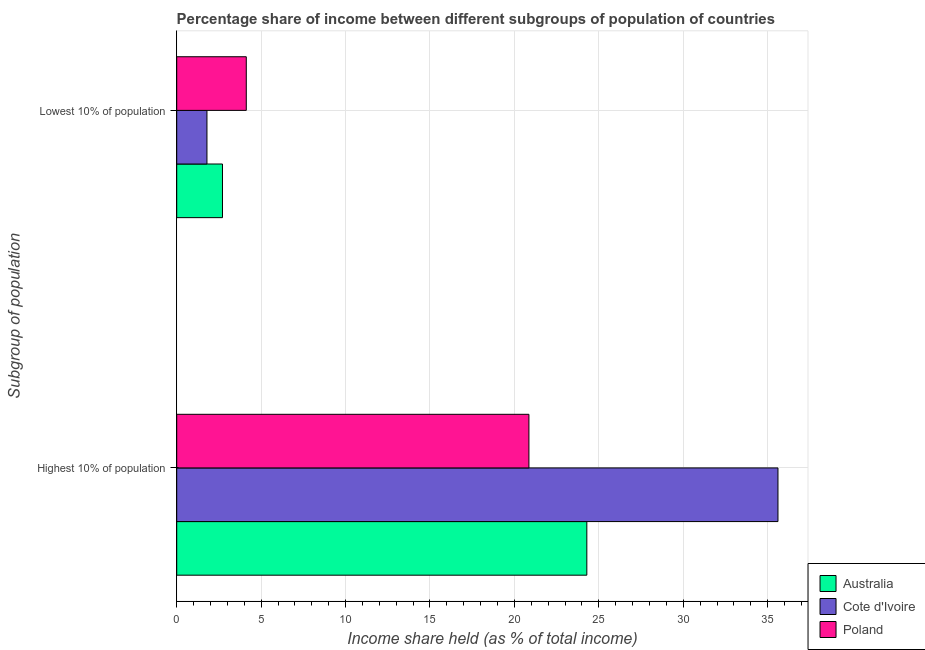How many groups of bars are there?
Provide a succinct answer. 2. How many bars are there on the 2nd tick from the top?
Your answer should be very brief. 3. How many bars are there on the 1st tick from the bottom?
Offer a terse response. 3. What is the label of the 1st group of bars from the top?
Provide a short and direct response. Lowest 10% of population. What is the income share held by lowest 10% of the population in Australia?
Your answer should be compact. 2.71. Across all countries, what is the maximum income share held by lowest 10% of the population?
Your answer should be very brief. 4.12. Across all countries, what is the minimum income share held by lowest 10% of the population?
Offer a very short reply. 1.79. In which country was the income share held by highest 10% of the population minimum?
Your answer should be compact. Poland. What is the total income share held by highest 10% of the population in the graph?
Your answer should be compact. 80.76. What is the difference between the income share held by highest 10% of the population in Australia and that in Cote d'Ivoire?
Keep it short and to the point. -11.32. What is the difference between the income share held by lowest 10% of the population in Australia and the income share held by highest 10% of the population in Cote d'Ivoire?
Offer a very short reply. -32.9. What is the average income share held by highest 10% of the population per country?
Your response must be concise. 26.92. What is the difference between the income share held by lowest 10% of the population and income share held by highest 10% of the population in Poland?
Make the answer very short. -16.74. What is the ratio of the income share held by highest 10% of the population in Poland to that in Cote d'Ivoire?
Provide a short and direct response. 0.59. What does the 2nd bar from the top in Highest 10% of population represents?
Provide a short and direct response. Cote d'Ivoire. What does the 3rd bar from the bottom in Lowest 10% of population represents?
Provide a short and direct response. Poland. How many countries are there in the graph?
Your response must be concise. 3. What is the difference between two consecutive major ticks on the X-axis?
Keep it short and to the point. 5. Are the values on the major ticks of X-axis written in scientific E-notation?
Offer a terse response. No. Does the graph contain any zero values?
Your answer should be very brief. No. How many legend labels are there?
Keep it short and to the point. 3. How are the legend labels stacked?
Give a very brief answer. Vertical. What is the title of the graph?
Your answer should be very brief. Percentage share of income between different subgroups of population of countries. Does "Cote d'Ivoire" appear as one of the legend labels in the graph?
Provide a short and direct response. Yes. What is the label or title of the X-axis?
Keep it short and to the point. Income share held (as % of total income). What is the label or title of the Y-axis?
Provide a succinct answer. Subgroup of population. What is the Income share held (as % of total income) in Australia in Highest 10% of population?
Provide a succinct answer. 24.29. What is the Income share held (as % of total income) in Cote d'Ivoire in Highest 10% of population?
Ensure brevity in your answer.  35.61. What is the Income share held (as % of total income) in Poland in Highest 10% of population?
Your answer should be compact. 20.86. What is the Income share held (as % of total income) of Australia in Lowest 10% of population?
Provide a short and direct response. 2.71. What is the Income share held (as % of total income) of Cote d'Ivoire in Lowest 10% of population?
Offer a very short reply. 1.79. What is the Income share held (as % of total income) in Poland in Lowest 10% of population?
Your answer should be compact. 4.12. Across all Subgroup of population, what is the maximum Income share held (as % of total income) of Australia?
Give a very brief answer. 24.29. Across all Subgroup of population, what is the maximum Income share held (as % of total income) of Cote d'Ivoire?
Your answer should be very brief. 35.61. Across all Subgroup of population, what is the maximum Income share held (as % of total income) in Poland?
Provide a short and direct response. 20.86. Across all Subgroup of population, what is the minimum Income share held (as % of total income) in Australia?
Provide a succinct answer. 2.71. Across all Subgroup of population, what is the minimum Income share held (as % of total income) of Cote d'Ivoire?
Ensure brevity in your answer.  1.79. Across all Subgroup of population, what is the minimum Income share held (as % of total income) in Poland?
Give a very brief answer. 4.12. What is the total Income share held (as % of total income) in Australia in the graph?
Your answer should be very brief. 27. What is the total Income share held (as % of total income) in Cote d'Ivoire in the graph?
Give a very brief answer. 37.4. What is the total Income share held (as % of total income) in Poland in the graph?
Give a very brief answer. 24.98. What is the difference between the Income share held (as % of total income) of Australia in Highest 10% of population and that in Lowest 10% of population?
Provide a succinct answer. 21.58. What is the difference between the Income share held (as % of total income) in Cote d'Ivoire in Highest 10% of population and that in Lowest 10% of population?
Your response must be concise. 33.82. What is the difference between the Income share held (as % of total income) in Poland in Highest 10% of population and that in Lowest 10% of population?
Your response must be concise. 16.74. What is the difference between the Income share held (as % of total income) in Australia in Highest 10% of population and the Income share held (as % of total income) in Cote d'Ivoire in Lowest 10% of population?
Your response must be concise. 22.5. What is the difference between the Income share held (as % of total income) in Australia in Highest 10% of population and the Income share held (as % of total income) in Poland in Lowest 10% of population?
Your response must be concise. 20.17. What is the difference between the Income share held (as % of total income) in Cote d'Ivoire in Highest 10% of population and the Income share held (as % of total income) in Poland in Lowest 10% of population?
Ensure brevity in your answer.  31.49. What is the average Income share held (as % of total income) in Australia per Subgroup of population?
Your answer should be compact. 13.5. What is the average Income share held (as % of total income) of Cote d'Ivoire per Subgroup of population?
Your answer should be compact. 18.7. What is the average Income share held (as % of total income) of Poland per Subgroup of population?
Your answer should be compact. 12.49. What is the difference between the Income share held (as % of total income) of Australia and Income share held (as % of total income) of Cote d'Ivoire in Highest 10% of population?
Keep it short and to the point. -11.32. What is the difference between the Income share held (as % of total income) of Australia and Income share held (as % of total income) of Poland in Highest 10% of population?
Your answer should be compact. 3.43. What is the difference between the Income share held (as % of total income) in Cote d'Ivoire and Income share held (as % of total income) in Poland in Highest 10% of population?
Provide a short and direct response. 14.75. What is the difference between the Income share held (as % of total income) of Australia and Income share held (as % of total income) of Poland in Lowest 10% of population?
Keep it short and to the point. -1.41. What is the difference between the Income share held (as % of total income) of Cote d'Ivoire and Income share held (as % of total income) of Poland in Lowest 10% of population?
Make the answer very short. -2.33. What is the ratio of the Income share held (as % of total income) of Australia in Highest 10% of population to that in Lowest 10% of population?
Ensure brevity in your answer.  8.96. What is the ratio of the Income share held (as % of total income) in Cote d'Ivoire in Highest 10% of population to that in Lowest 10% of population?
Give a very brief answer. 19.89. What is the ratio of the Income share held (as % of total income) in Poland in Highest 10% of population to that in Lowest 10% of population?
Keep it short and to the point. 5.06. What is the difference between the highest and the second highest Income share held (as % of total income) of Australia?
Your answer should be very brief. 21.58. What is the difference between the highest and the second highest Income share held (as % of total income) in Cote d'Ivoire?
Your answer should be compact. 33.82. What is the difference between the highest and the second highest Income share held (as % of total income) in Poland?
Provide a short and direct response. 16.74. What is the difference between the highest and the lowest Income share held (as % of total income) in Australia?
Make the answer very short. 21.58. What is the difference between the highest and the lowest Income share held (as % of total income) in Cote d'Ivoire?
Keep it short and to the point. 33.82. What is the difference between the highest and the lowest Income share held (as % of total income) in Poland?
Your answer should be compact. 16.74. 